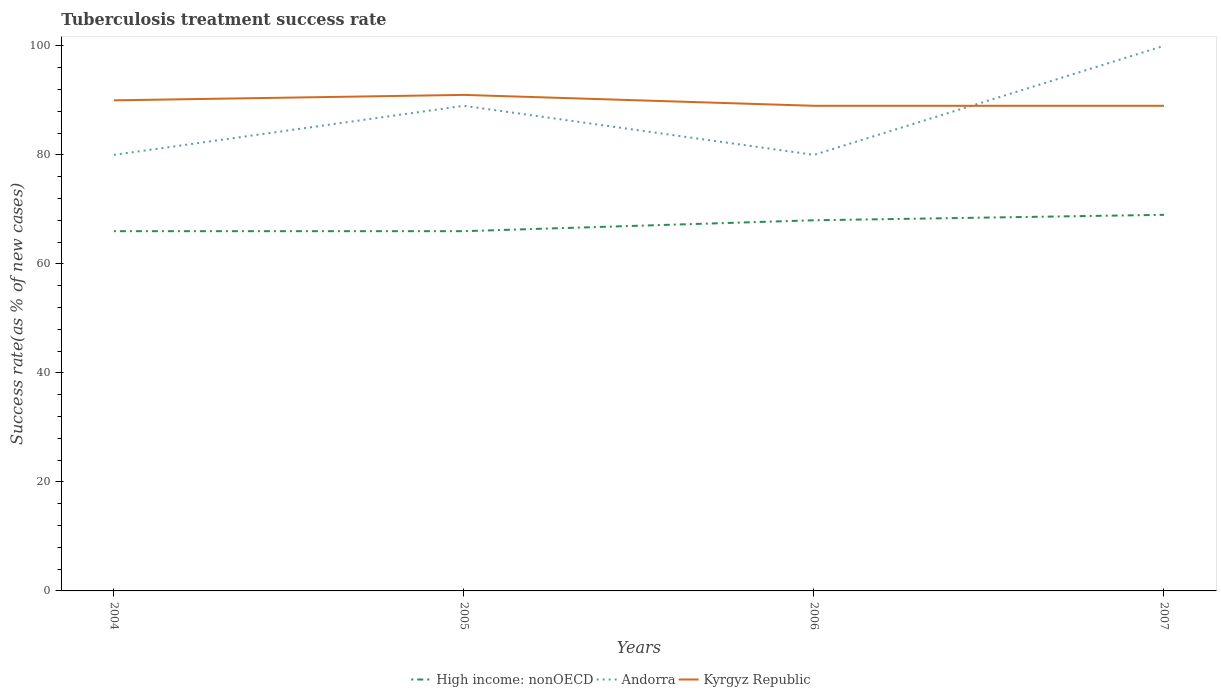How many different coloured lines are there?
Provide a succinct answer. 3. Across all years, what is the maximum tuberculosis treatment success rate in Kyrgyz Republic?
Your answer should be very brief. 89. What is the total tuberculosis treatment success rate in High income: nonOECD in the graph?
Your answer should be compact. -2. What is the difference between the highest and the second highest tuberculosis treatment success rate in Andorra?
Your answer should be compact. 20. Is the tuberculosis treatment success rate in Kyrgyz Republic strictly greater than the tuberculosis treatment success rate in High income: nonOECD over the years?
Your response must be concise. No. How many years are there in the graph?
Offer a terse response. 4. Where does the legend appear in the graph?
Your response must be concise. Bottom center. How many legend labels are there?
Ensure brevity in your answer.  3. What is the title of the graph?
Keep it short and to the point. Tuberculosis treatment success rate. Does "West Bank and Gaza" appear as one of the legend labels in the graph?
Give a very brief answer. No. What is the label or title of the X-axis?
Your response must be concise. Years. What is the label or title of the Y-axis?
Give a very brief answer. Success rate(as % of new cases). What is the Success rate(as % of new cases) of High income: nonOECD in 2004?
Provide a succinct answer. 66. What is the Success rate(as % of new cases) of Andorra in 2004?
Offer a terse response. 80. What is the Success rate(as % of new cases) of High income: nonOECD in 2005?
Provide a succinct answer. 66. What is the Success rate(as % of new cases) of Andorra in 2005?
Your response must be concise. 89. What is the Success rate(as % of new cases) in Kyrgyz Republic in 2005?
Keep it short and to the point. 91. What is the Success rate(as % of new cases) in Kyrgyz Republic in 2006?
Offer a terse response. 89. What is the Success rate(as % of new cases) of Kyrgyz Republic in 2007?
Provide a succinct answer. 89. Across all years, what is the maximum Success rate(as % of new cases) of High income: nonOECD?
Your answer should be very brief. 69. Across all years, what is the maximum Success rate(as % of new cases) of Kyrgyz Republic?
Ensure brevity in your answer.  91. Across all years, what is the minimum Success rate(as % of new cases) in Andorra?
Provide a succinct answer. 80. Across all years, what is the minimum Success rate(as % of new cases) of Kyrgyz Republic?
Your answer should be very brief. 89. What is the total Success rate(as % of new cases) in High income: nonOECD in the graph?
Keep it short and to the point. 269. What is the total Success rate(as % of new cases) of Andorra in the graph?
Provide a succinct answer. 349. What is the total Success rate(as % of new cases) of Kyrgyz Republic in the graph?
Keep it short and to the point. 359. What is the difference between the Success rate(as % of new cases) in Kyrgyz Republic in 2004 and that in 2005?
Your answer should be very brief. -1. What is the difference between the Success rate(as % of new cases) of High income: nonOECD in 2004 and that in 2006?
Your response must be concise. -2. What is the difference between the Success rate(as % of new cases) in High income: nonOECD in 2004 and that in 2007?
Your answer should be compact. -3. What is the difference between the Success rate(as % of new cases) in High income: nonOECD in 2005 and that in 2006?
Ensure brevity in your answer.  -2. What is the difference between the Success rate(as % of new cases) of High income: nonOECD in 2005 and that in 2007?
Keep it short and to the point. -3. What is the difference between the Success rate(as % of new cases) in Andorra in 2005 and that in 2007?
Your response must be concise. -11. What is the difference between the Success rate(as % of new cases) of Kyrgyz Republic in 2005 and that in 2007?
Keep it short and to the point. 2. What is the difference between the Success rate(as % of new cases) of High income: nonOECD in 2006 and that in 2007?
Provide a succinct answer. -1. What is the difference between the Success rate(as % of new cases) of Andorra in 2006 and that in 2007?
Ensure brevity in your answer.  -20. What is the difference between the Success rate(as % of new cases) of Andorra in 2004 and the Success rate(as % of new cases) of Kyrgyz Republic in 2005?
Keep it short and to the point. -11. What is the difference between the Success rate(as % of new cases) in High income: nonOECD in 2004 and the Success rate(as % of new cases) in Kyrgyz Republic in 2006?
Your response must be concise. -23. What is the difference between the Success rate(as % of new cases) of High income: nonOECD in 2004 and the Success rate(as % of new cases) of Andorra in 2007?
Make the answer very short. -34. What is the difference between the Success rate(as % of new cases) in High income: nonOECD in 2005 and the Success rate(as % of new cases) in Andorra in 2006?
Offer a terse response. -14. What is the difference between the Success rate(as % of new cases) of Andorra in 2005 and the Success rate(as % of new cases) of Kyrgyz Republic in 2006?
Your answer should be very brief. 0. What is the difference between the Success rate(as % of new cases) of High income: nonOECD in 2005 and the Success rate(as % of new cases) of Andorra in 2007?
Provide a short and direct response. -34. What is the difference between the Success rate(as % of new cases) in High income: nonOECD in 2005 and the Success rate(as % of new cases) in Kyrgyz Republic in 2007?
Keep it short and to the point. -23. What is the difference between the Success rate(as % of new cases) in High income: nonOECD in 2006 and the Success rate(as % of new cases) in Andorra in 2007?
Give a very brief answer. -32. What is the difference between the Success rate(as % of new cases) in High income: nonOECD in 2006 and the Success rate(as % of new cases) in Kyrgyz Republic in 2007?
Provide a short and direct response. -21. What is the average Success rate(as % of new cases) in High income: nonOECD per year?
Your answer should be compact. 67.25. What is the average Success rate(as % of new cases) in Andorra per year?
Your answer should be compact. 87.25. What is the average Success rate(as % of new cases) in Kyrgyz Republic per year?
Make the answer very short. 89.75. In the year 2004, what is the difference between the Success rate(as % of new cases) in High income: nonOECD and Success rate(as % of new cases) in Andorra?
Provide a short and direct response. -14. In the year 2004, what is the difference between the Success rate(as % of new cases) in High income: nonOECD and Success rate(as % of new cases) in Kyrgyz Republic?
Offer a terse response. -24. In the year 2004, what is the difference between the Success rate(as % of new cases) in Andorra and Success rate(as % of new cases) in Kyrgyz Republic?
Offer a terse response. -10. In the year 2006, what is the difference between the Success rate(as % of new cases) of High income: nonOECD and Success rate(as % of new cases) of Andorra?
Your answer should be very brief. -12. In the year 2007, what is the difference between the Success rate(as % of new cases) of High income: nonOECD and Success rate(as % of new cases) of Andorra?
Ensure brevity in your answer.  -31. What is the ratio of the Success rate(as % of new cases) in High income: nonOECD in 2004 to that in 2005?
Your answer should be very brief. 1. What is the ratio of the Success rate(as % of new cases) in Andorra in 2004 to that in 2005?
Keep it short and to the point. 0.9. What is the ratio of the Success rate(as % of new cases) in Kyrgyz Republic in 2004 to that in 2005?
Offer a very short reply. 0.99. What is the ratio of the Success rate(as % of new cases) of High income: nonOECD in 2004 to that in 2006?
Your answer should be compact. 0.97. What is the ratio of the Success rate(as % of new cases) in Andorra in 2004 to that in 2006?
Your answer should be very brief. 1. What is the ratio of the Success rate(as % of new cases) of Kyrgyz Republic in 2004 to that in 2006?
Your answer should be compact. 1.01. What is the ratio of the Success rate(as % of new cases) in High income: nonOECD in 2004 to that in 2007?
Ensure brevity in your answer.  0.96. What is the ratio of the Success rate(as % of new cases) of Andorra in 2004 to that in 2007?
Provide a succinct answer. 0.8. What is the ratio of the Success rate(as % of new cases) in Kyrgyz Republic in 2004 to that in 2007?
Offer a very short reply. 1.01. What is the ratio of the Success rate(as % of new cases) in High income: nonOECD in 2005 to that in 2006?
Offer a very short reply. 0.97. What is the ratio of the Success rate(as % of new cases) of Andorra in 2005 to that in 2006?
Offer a terse response. 1.11. What is the ratio of the Success rate(as % of new cases) in Kyrgyz Republic in 2005 to that in 2006?
Your response must be concise. 1.02. What is the ratio of the Success rate(as % of new cases) of High income: nonOECD in 2005 to that in 2007?
Provide a succinct answer. 0.96. What is the ratio of the Success rate(as % of new cases) of Andorra in 2005 to that in 2007?
Your answer should be very brief. 0.89. What is the ratio of the Success rate(as % of new cases) of Kyrgyz Republic in 2005 to that in 2007?
Keep it short and to the point. 1.02. What is the ratio of the Success rate(as % of new cases) of High income: nonOECD in 2006 to that in 2007?
Ensure brevity in your answer.  0.99. What is the ratio of the Success rate(as % of new cases) in Andorra in 2006 to that in 2007?
Your response must be concise. 0.8. What is the difference between the highest and the second highest Success rate(as % of new cases) in High income: nonOECD?
Your response must be concise. 1. What is the difference between the highest and the second highest Success rate(as % of new cases) of Andorra?
Offer a terse response. 11. What is the difference between the highest and the second highest Success rate(as % of new cases) in Kyrgyz Republic?
Keep it short and to the point. 1. What is the difference between the highest and the lowest Success rate(as % of new cases) of High income: nonOECD?
Keep it short and to the point. 3. 